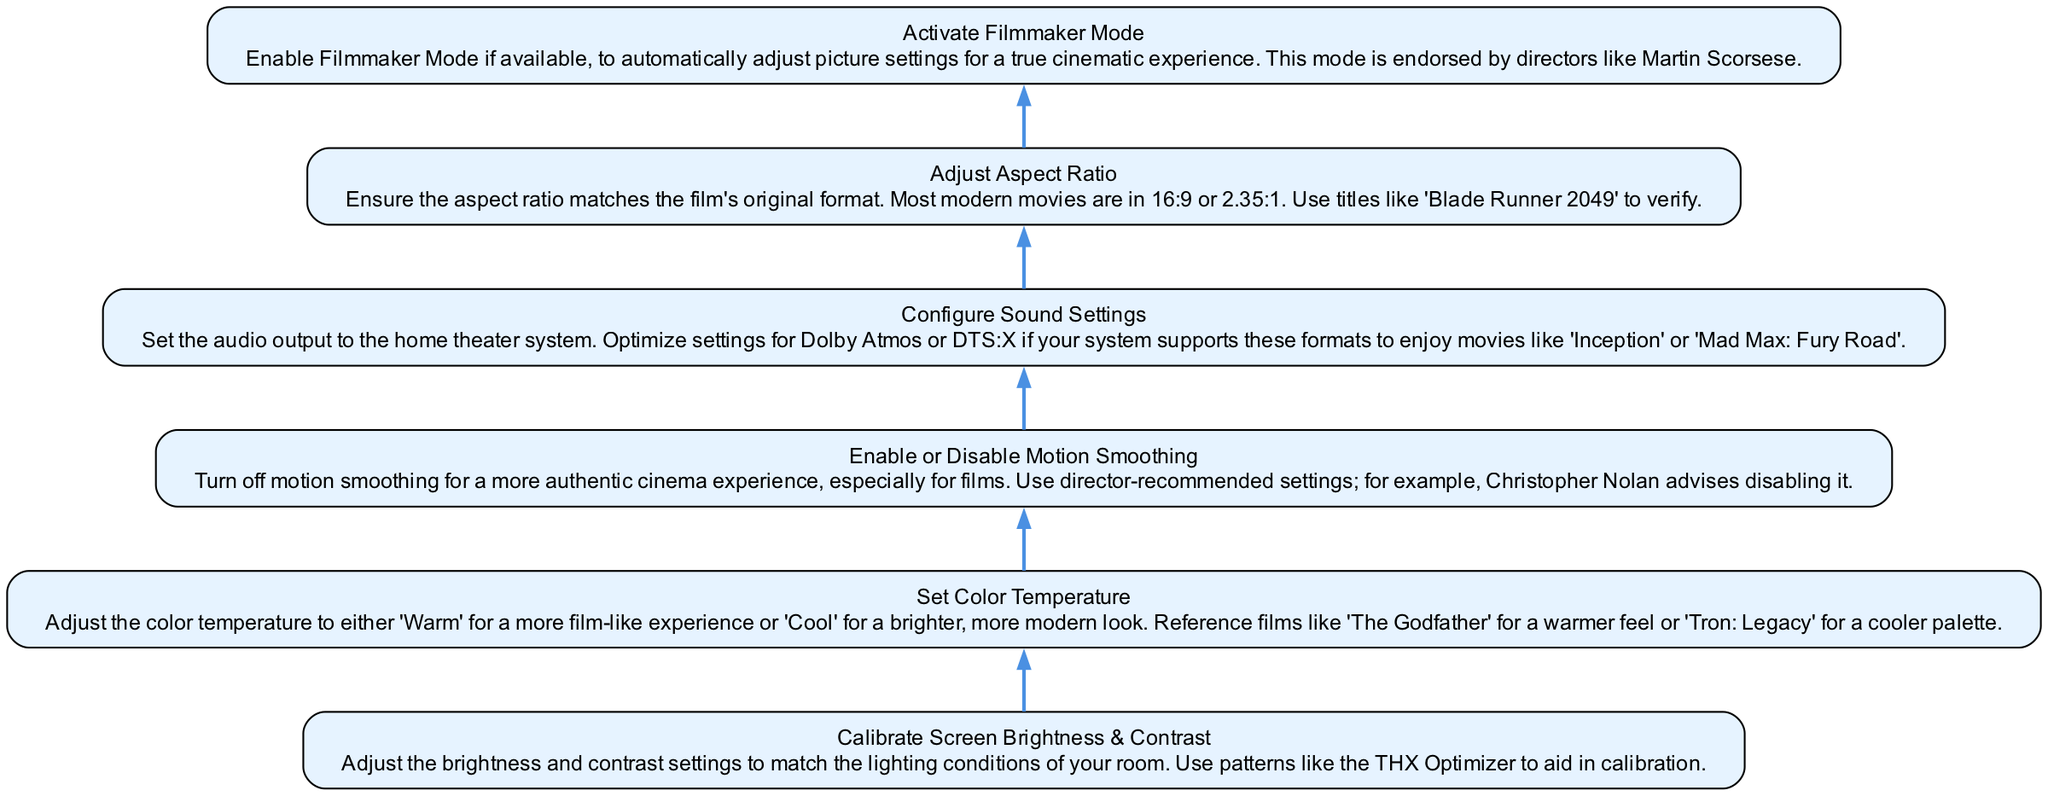What is the first step in customizing viewing settings? The first step in the diagram is "Calibrate Screen Brightness & Contrast," which is the node at the bottom. There are no preceding nodes before this one, indicating that it is the starting point.
Answer: Calibrate Screen Brightness & Contrast Which mode should be activated for a true cinematic experience? The diagram states that "Activate Filmmaker Mode" should be enabled if available. This is indicated as a recommended action for achieving the desired experience after calibrating settings.
Answer: Activate Filmmaker Mode How many nodes are there in the diagram? By counting each action in the flow chart, there are a total of six nodes. Each action from "Calibrate Screen Brightness & Contrast" to "Activate Filmmaker Mode" represents a node in this flow.
Answer: Six What setting is recommended to enhance audio experience? According to the diagram, "Configure Sound Settings" is the step that addresses enhancing audio experience, specifically for setups like Dolby Atmos.
Answer: Configure Sound Settings What action is advised before adjusting color settings? The flow suggests that before setting color temperature, one should first "Calibrate Screen Brightness & Contrast," as this ensures that any color adjustments are made in the right lighting conditions.
Answer: Calibrate Screen Brightness & Contrast What should be done regarding motion smoothing? The diagram indicates that you should "Enable or Disable Motion Smoothing." This is a critical action for achieving an authentic cinema experience, especially for films.
Answer: Turn off motion smoothing Which films are referenced for achieving optimal color temperature? The optimal color settings can be influenced by films like "The Godfather" for a warmer feel and "Tron: Legacy" for a cooler setting. Both titles are suggested in the context of setting color temperature.
Answer: The Godfather and Tron: Legacy What is the relationship between "Set Color Temperature" and "Calibrate Screen Brightness & Contrast"? "Calibrate Screen Brightness & Contrast" is the first step to be completed before "Set Color Temperature." The initial calibration of brightness and contrast helps in making accurate adjustments to the color settings that follow.
Answer: Sequential relationship Which aspect ratio should be adjusted according to most modern movies? It is indicated in the diagram that the aspect ratio for modern movies is typically either 16:9 or 2.35:1. Adjusting to these formats is essential for the best viewing experience.
Answer: 16:9 or 2.35:1 